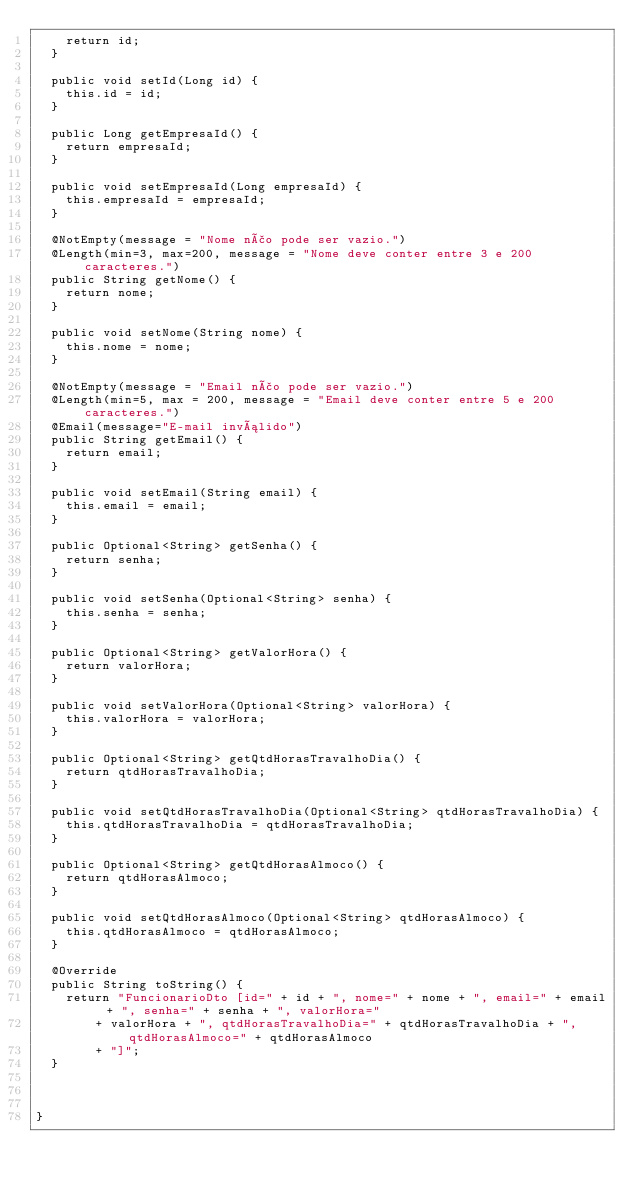Convert code to text. <code><loc_0><loc_0><loc_500><loc_500><_Java_>		return id;
	}

	public void setId(Long id) {
		this.id = id;
	}
	
	public Long getEmpresaId() {
		return empresaId;
	}
	
	public void setEmpresaId(Long empresaId) {
		this.empresaId = empresaId;
	}

	@NotEmpty(message = "Nome não pode ser vazio.")
	@Length(min=3, max=200, message = "Nome deve conter entre 3 e 200 caracteres.")
	public String getNome() {
		return nome;
	}

	public void setNome(String nome) {
		this.nome = nome;
	}

	@NotEmpty(message = "Email não pode ser vazio.")
	@Length(min=5, max = 200, message = "Email deve conter entre 5 e 200 caracteres.")
	@Email(message="E-mail inválido")
	public String getEmail() {
		return email;
	}

	public void setEmail(String email) {
		this.email = email;
	}
	
	public Optional<String> getSenha() {
		return senha;
	}

	public void setSenha(Optional<String> senha) {
		this.senha = senha;
	}

	public Optional<String> getValorHora() {
		return valorHora;
	}

	public void setValorHora(Optional<String> valorHora) {
		this.valorHora = valorHora;
	}

	public Optional<String> getQtdHorasTravalhoDia() {
		return qtdHorasTravalhoDia;
	}

	public void setQtdHorasTravalhoDia(Optional<String> qtdHorasTravalhoDia) {
		this.qtdHorasTravalhoDia = qtdHorasTravalhoDia;
	}

	public Optional<String> getQtdHorasAlmoco() {
		return qtdHorasAlmoco;
	}

	public void setQtdHorasAlmoco(Optional<String> qtdHorasAlmoco) {
		this.qtdHorasAlmoco = qtdHorasAlmoco;
	}

	@Override
	public String toString() {
		return "FuncionarioDto [id=" + id + ", nome=" + nome + ", email=" + email + ", senha=" + senha + ", valorHora="
				+ valorHora + ", qtdHorasTravalhoDia=" + qtdHorasTravalhoDia + ", qtdHorasAlmoco=" + qtdHorasAlmoco
				+ "]";
	}
	
	
	
}
</code> 